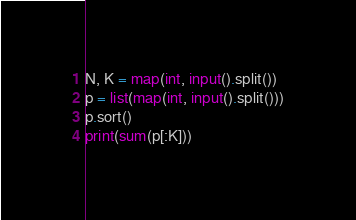Convert code to text. <code><loc_0><loc_0><loc_500><loc_500><_Python_>N, K = map(int, input().split())
p = list(map(int, input().split()))
p.sort()
print(sum(p[:K]))</code> 